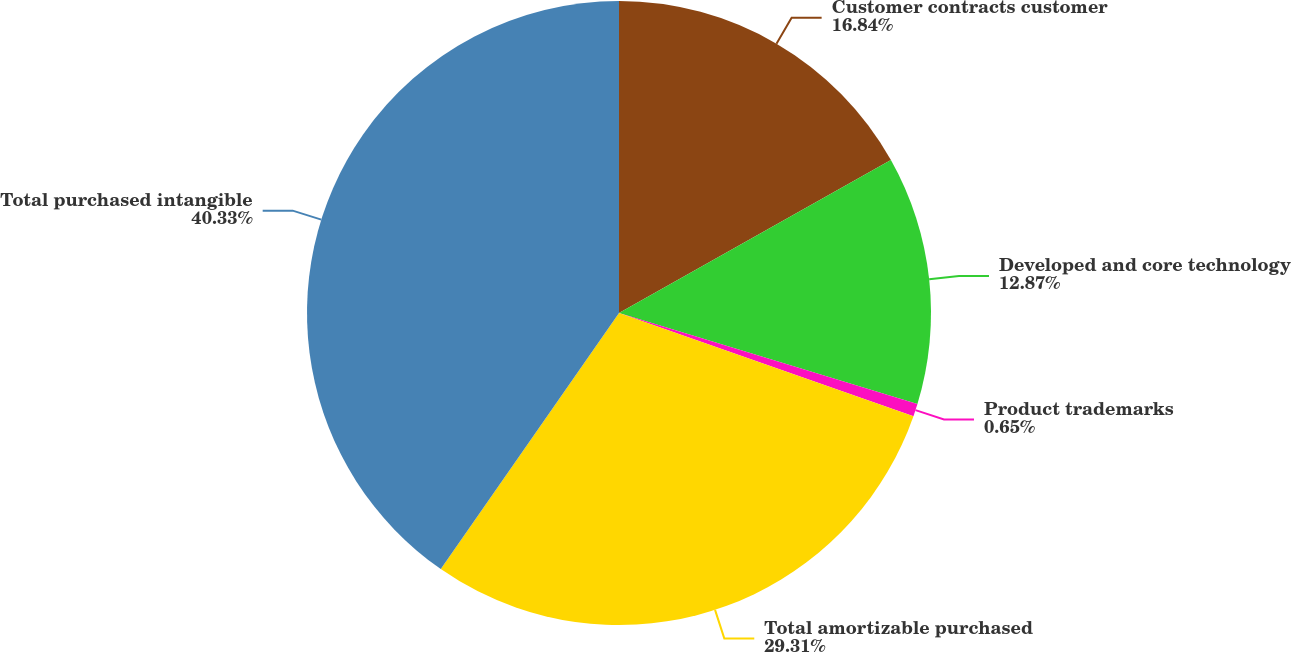<chart> <loc_0><loc_0><loc_500><loc_500><pie_chart><fcel>Customer contracts customer<fcel>Developed and core technology<fcel>Product trademarks<fcel>Total amortizable purchased<fcel>Total purchased intangible<nl><fcel>16.84%<fcel>12.87%<fcel>0.65%<fcel>29.31%<fcel>40.32%<nl></chart> 